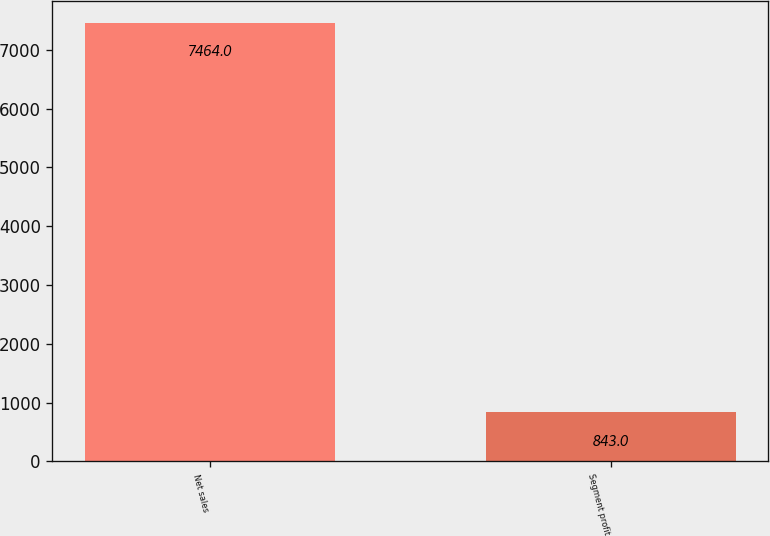Convert chart to OTSL. <chart><loc_0><loc_0><loc_500><loc_500><bar_chart><fcel>Net sales<fcel>Segment profit<nl><fcel>7464<fcel>843<nl></chart> 